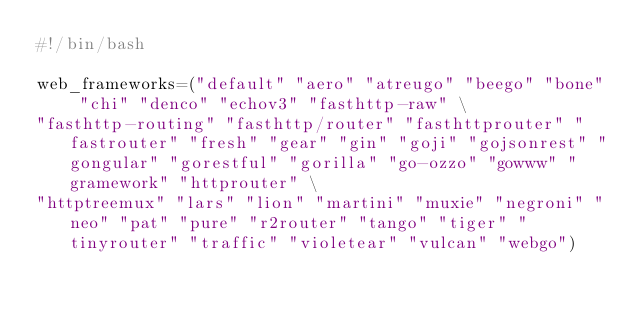Convert code to text. <code><loc_0><loc_0><loc_500><loc_500><_Bash_>#!/bin/bash

web_frameworks=("default" "aero" "atreugo" "beego" "bone" "chi" "denco" "echov3" "fasthttp-raw" \
"fasthttp-routing" "fasthttp/router" "fasthttprouter" "fastrouter" "fresh" "gear" "gin" "goji" "gojsonrest" "gongular" "gorestful" "gorilla" "go-ozzo" "gowww" "gramework" "httprouter" \
"httptreemux" "lars" "lion" "martini" "muxie" "negroni" "neo" "pat" "pure" "r2router" "tango" "tiger" "tinyrouter" "traffic" "violetear" "vulcan" "webgo")

</code> 